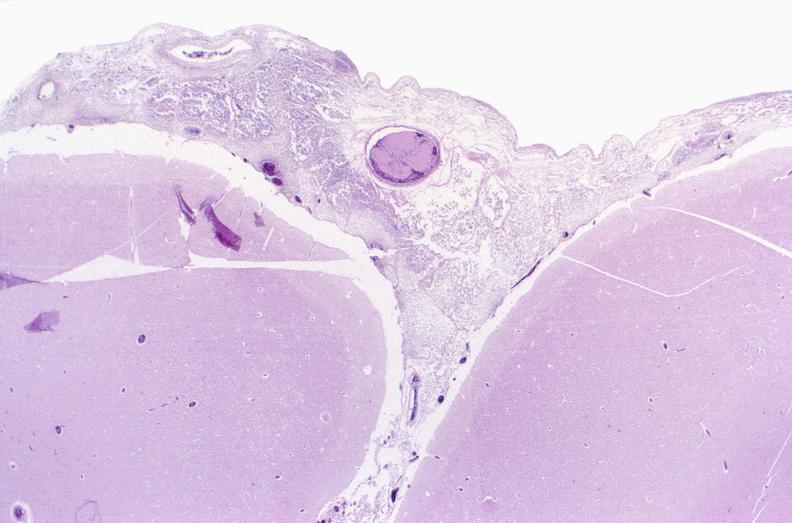s incidental finding present?
Answer the question using a single word or phrase. No 